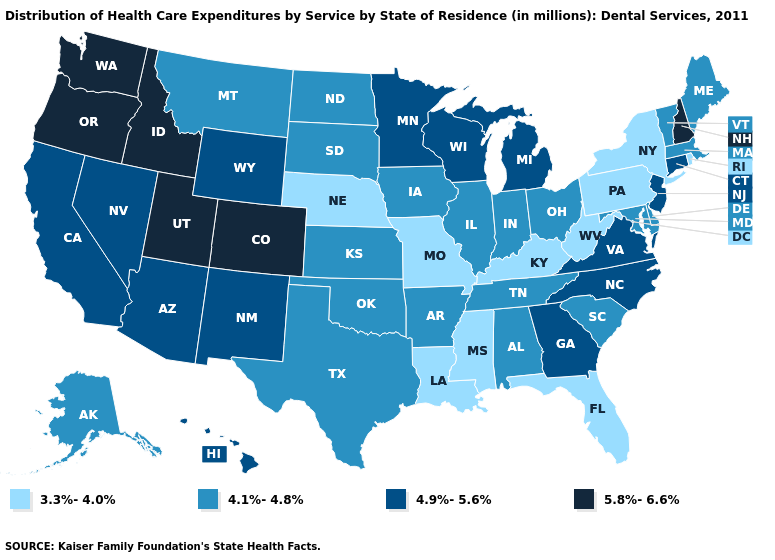Name the states that have a value in the range 5.8%-6.6%?
Short answer required. Colorado, Idaho, New Hampshire, Oregon, Utah, Washington. Among the states that border Arizona , does Colorado have the lowest value?
Keep it brief. No. Does Minnesota have the highest value in the MidWest?
Keep it brief. Yes. What is the highest value in states that border Ohio?
Write a very short answer. 4.9%-5.6%. What is the value of Kansas?
Short answer required. 4.1%-4.8%. What is the highest value in the USA?
Short answer required. 5.8%-6.6%. What is the value of Colorado?
Answer briefly. 5.8%-6.6%. Name the states that have a value in the range 4.9%-5.6%?
Keep it brief. Arizona, California, Connecticut, Georgia, Hawaii, Michigan, Minnesota, Nevada, New Jersey, New Mexico, North Carolina, Virginia, Wisconsin, Wyoming. Name the states that have a value in the range 5.8%-6.6%?
Short answer required. Colorado, Idaho, New Hampshire, Oregon, Utah, Washington. Among the states that border New York , which have the lowest value?
Answer briefly. Pennsylvania. Name the states that have a value in the range 5.8%-6.6%?
Keep it brief. Colorado, Idaho, New Hampshire, Oregon, Utah, Washington. What is the highest value in states that border Indiana?
Write a very short answer. 4.9%-5.6%. What is the highest value in states that border Texas?
Concise answer only. 4.9%-5.6%. What is the value of Maryland?
Answer briefly. 4.1%-4.8%. What is the value of Arizona?
Be succinct. 4.9%-5.6%. 